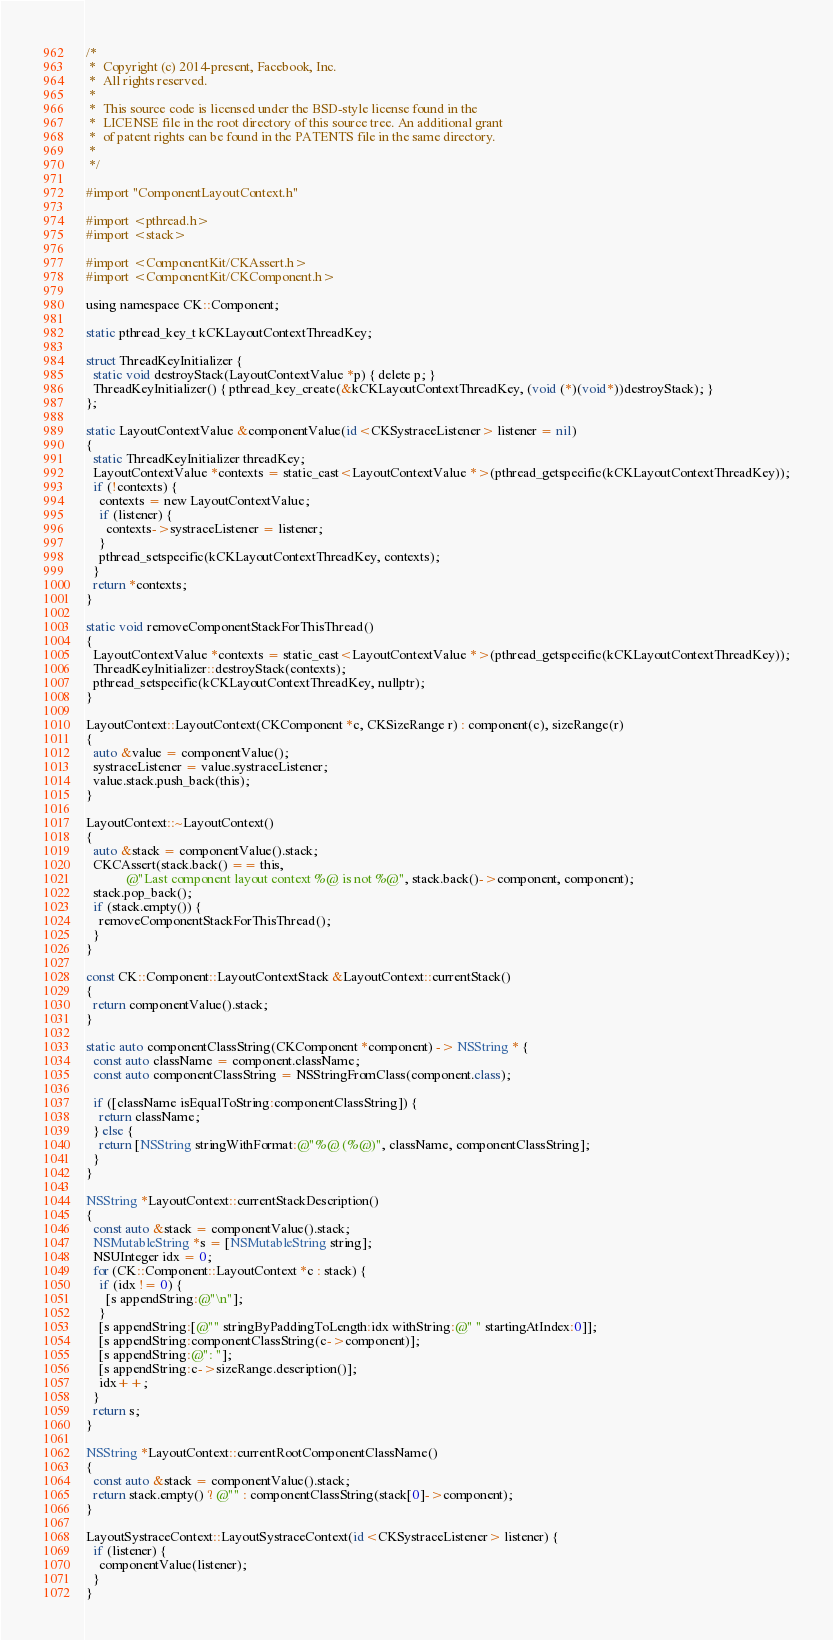Convert code to text. <code><loc_0><loc_0><loc_500><loc_500><_ObjectiveC_>/*
 *  Copyright (c) 2014-present, Facebook, Inc.
 *  All rights reserved.
 *
 *  This source code is licensed under the BSD-style license found in the
 *  LICENSE file in the root directory of this source tree. An additional grant
 *  of patent rights can be found in the PATENTS file in the same directory.
 *
 */

#import "ComponentLayoutContext.h"

#import <pthread.h>
#import <stack>

#import <ComponentKit/CKAssert.h>
#import <ComponentKit/CKComponent.h>

using namespace CK::Component;

static pthread_key_t kCKLayoutContextThreadKey;

struct ThreadKeyInitializer {
  static void destroyStack(LayoutContextValue *p) { delete p; }
  ThreadKeyInitializer() { pthread_key_create(&kCKLayoutContextThreadKey, (void (*)(void*))destroyStack); }
};

static LayoutContextValue &componentValue(id<CKSystraceListener> listener = nil)
{
  static ThreadKeyInitializer threadKey;
  LayoutContextValue *contexts = static_cast<LayoutContextValue *>(pthread_getspecific(kCKLayoutContextThreadKey));
  if (!contexts) {
    contexts = new LayoutContextValue;
    if (listener) {
      contexts->systraceListener = listener;
    }
    pthread_setspecific(kCKLayoutContextThreadKey, contexts);
  }
  return *contexts;
}

static void removeComponentStackForThisThread()
{
  LayoutContextValue *contexts = static_cast<LayoutContextValue *>(pthread_getspecific(kCKLayoutContextThreadKey));
  ThreadKeyInitializer::destroyStack(contexts);
  pthread_setspecific(kCKLayoutContextThreadKey, nullptr);
}

LayoutContext::LayoutContext(CKComponent *c, CKSizeRange r) : component(c), sizeRange(r)
{
  auto &value = componentValue();
  systraceListener = value.systraceListener;
  value.stack.push_back(this);
}

LayoutContext::~LayoutContext()
{
  auto &stack = componentValue().stack;
  CKCAssert(stack.back() == this,
            @"Last component layout context %@ is not %@", stack.back()->component, component);
  stack.pop_back();
  if (stack.empty()) {
    removeComponentStackForThisThread();
  }
}

const CK::Component::LayoutContextStack &LayoutContext::currentStack()
{
  return componentValue().stack;
}

static auto componentClassString(CKComponent *component) -> NSString * {
  const auto className = component.className;
  const auto componentClassString = NSStringFromClass(component.class);

  if ([className isEqualToString:componentClassString]) {
    return className;
  } else {
    return [NSString stringWithFormat:@"%@ (%@)", className, componentClassString];
  }
}

NSString *LayoutContext::currentStackDescription()
{
  const auto &stack = componentValue().stack;
  NSMutableString *s = [NSMutableString string];
  NSUInteger idx = 0;
  for (CK::Component::LayoutContext *c : stack) {
    if (idx != 0) {
      [s appendString:@"\n"];
    }
    [s appendString:[@"" stringByPaddingToLength:idx withString:@" " startingAtIndex:0]];
    [s appendString:componentClassString(c->component)];
    [s appendString:@": "];
    [s appendString:c->sizeRange.description()];
    idx++;
  }
  return s;
}

NSString *LayoutContext::currentRootComponentClassName()
{
  const auto &stack = componentValue().stack;
  return stack.empty() ? @"" : componentClassString(stack[0]->component);
}

LayoutSystraceContext::LayoutSystraceContext(id<CKSystraceListener> listener) {
  if (listener) {
    componentValue(listener);
  }
}
</code> 